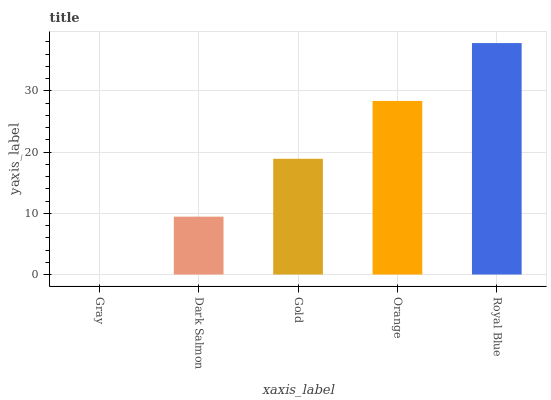Is Gray the minimum?
Answer yes or no. Yes. Is Royal Blue the maximum?
Answer yes or no. Yes. Is Dark Salmon the minimum?
Answer yes or no. No. Is Dark Salmon the maximum?
Answer yes or no. No. Is Dark Salmon greater than Gray?
Answer yes or no. Yes. Is Gray less than Dark Salmon?
Answer yes or no. Yes. Is Gray greater than Dark Salmon?
Answer yes or no. No. Is Dark Salmon less than Gray?
Answer yes or no. No. Is Gold the high median?
Answer yes or no. Yes. Is Gold the low median?
Answer yes or no. Yes. Is Orange the high median?
Answer yes or no. No. Is Gray the low median?
Answer yes or no. No. 